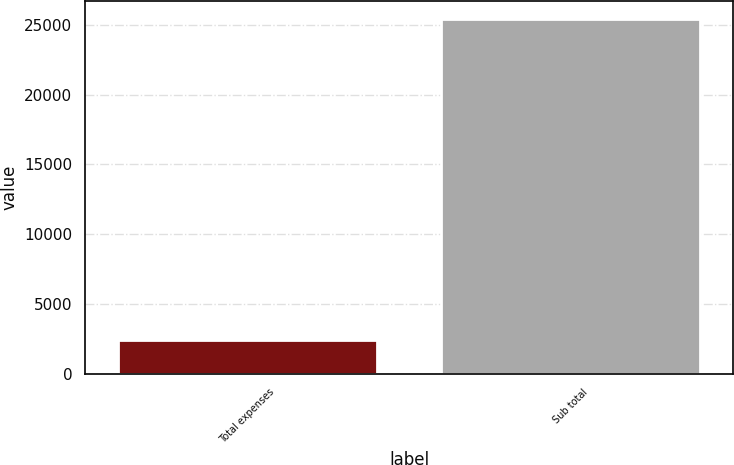<chart> <loc_0><loc_0><loc_500><loc_500><bar_chart><fcel>Total expenses<fcel>Sub total<nl><fcel>2433<fcel>25432<nl></chart> 